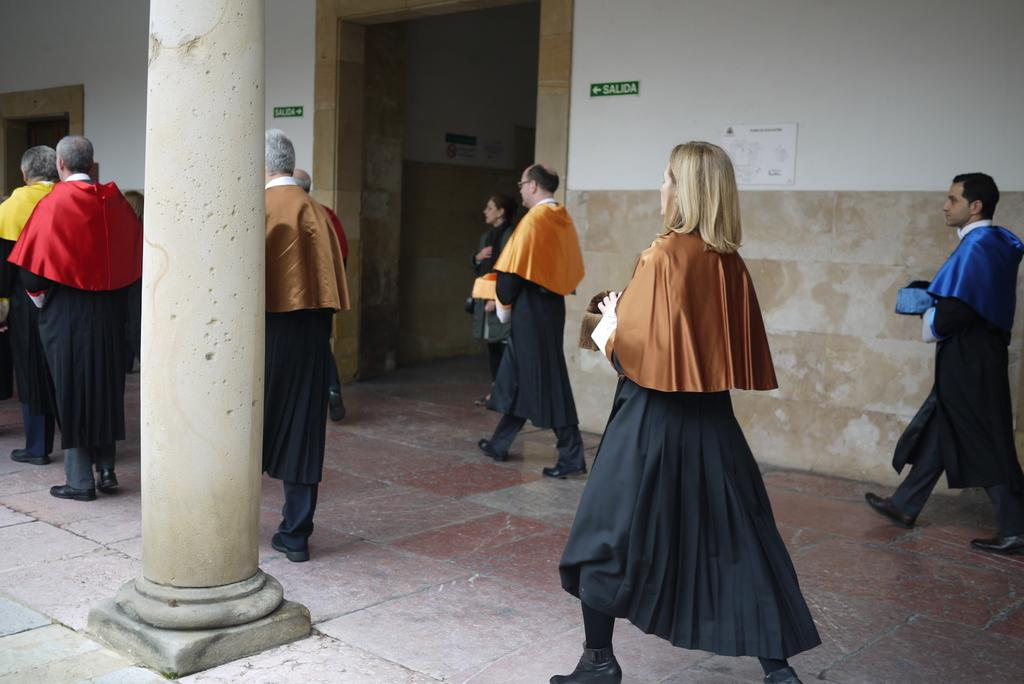What are the people in the image doing? There is a group of people walking in the image. What can be seen in the background of the image? There are direction boards, papers on the walls, and pillars in the background of the image. What type of calculator is being used by the authority figure in the image? There is no calculator or authority figure present in the image. 